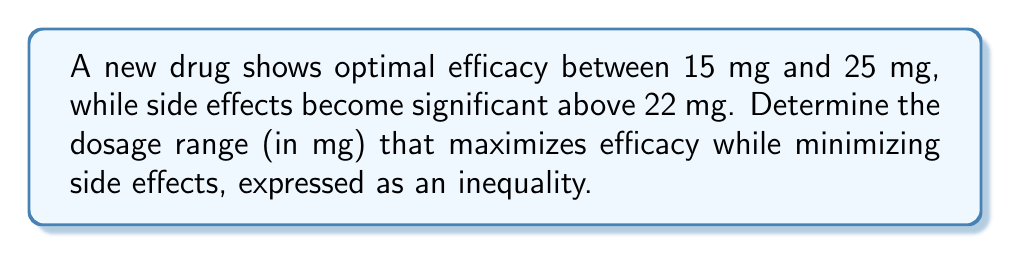Solve this math problem. To solve this problem, we need to consider two constraints:

1. Efficacy range: $15 \leq x \leq 25$, where $x$ is the dosage in mg.
2. Side effect threshold: $x < 22$ mg (we use strict inequality to minimize side effects).

Step 1: Combine the lower bound of efficacy with the upper bound of side effects.
$15 \leq x < 22$

Step 2: Express the final inequality.
The optimal dosage range is represented by the intersection of these two constraints:

$$15 \leq x < 22$$

This inequality represents the dosage range that maximizes efficacy while minimizing side effects. It ensures that the dosage is at least 15 mg for optimal efficacy but strictly less than 22 mg to avoid significant side effects.
Answer: $15 \leq x < 22$ 